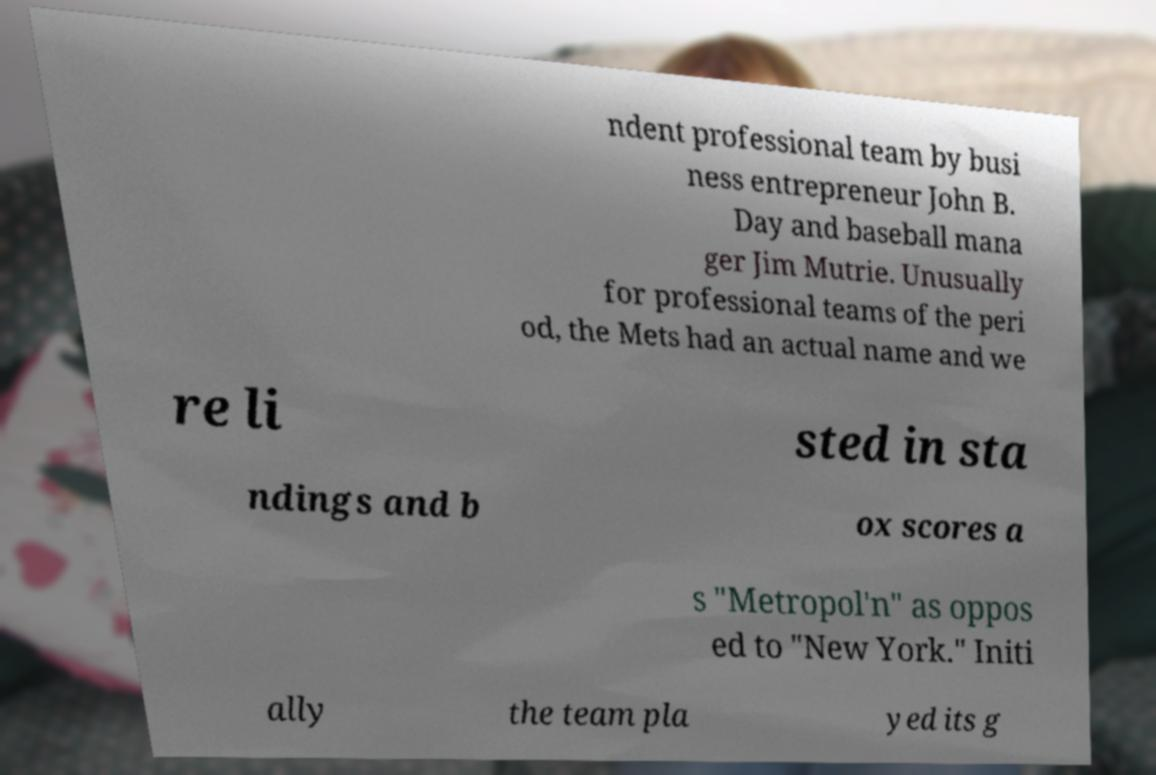Could you assist in decoding the text presented in this image and type it out clearly? ndent professional team by busi ness entrepreneur John B. Day and baseball mana ger Jim Mutrie. Unusually for professional teams of the peri od, the Mets had an actual name and we re li sted in sta ndings and b ox scores a s "Metropol'n" as oppos ed to "New York." Initi ally the team pla yed its g 